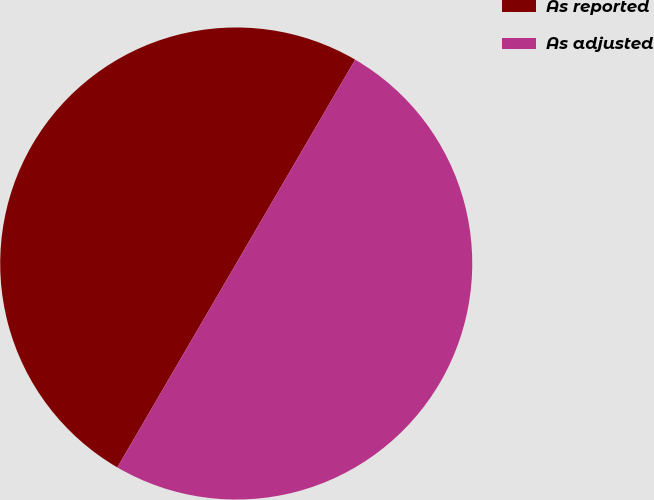<chart> <loc_0><loc_0><loc_500><loc_500><pie_chart><fcel>As reported<fcel>As adjusted<nl><fcel>50.0%<fcel>50.0%<nl></chart> 